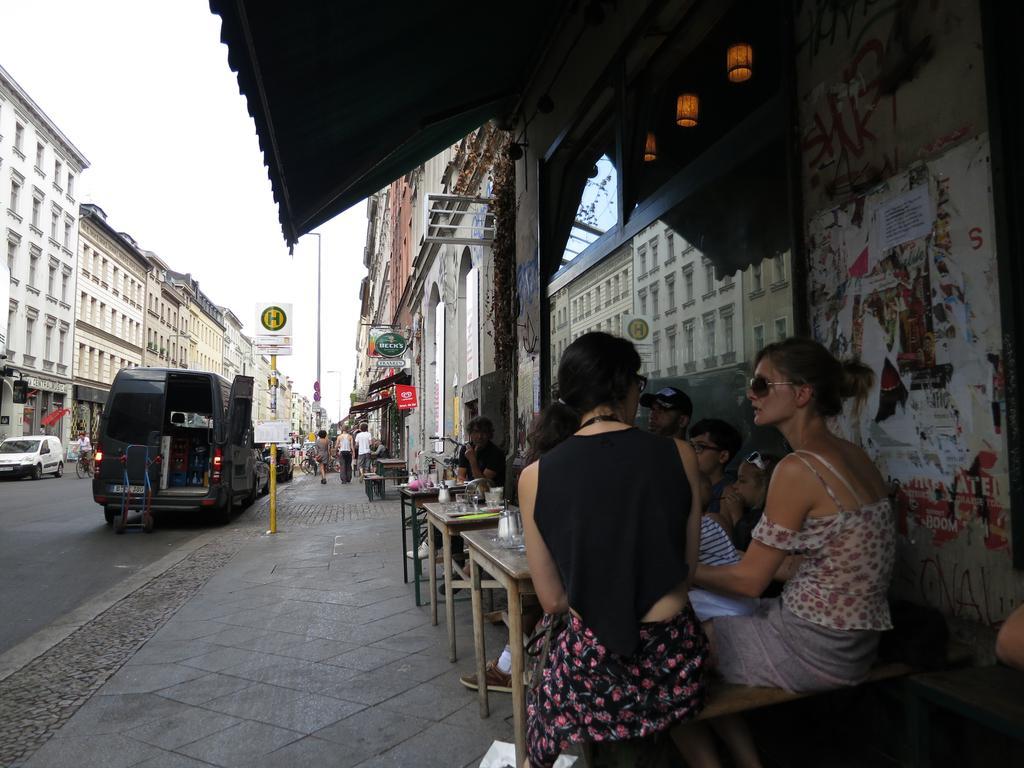In one or two sentences, can you explain what this image depicts? In this image I can see there are few persons visible in front of the table , on the table I can see glasses and persons sitting in side the building and I can see a road , on the road I can see persons and vehicles and buildings and signboard and pole and at the top I can see the sky. 